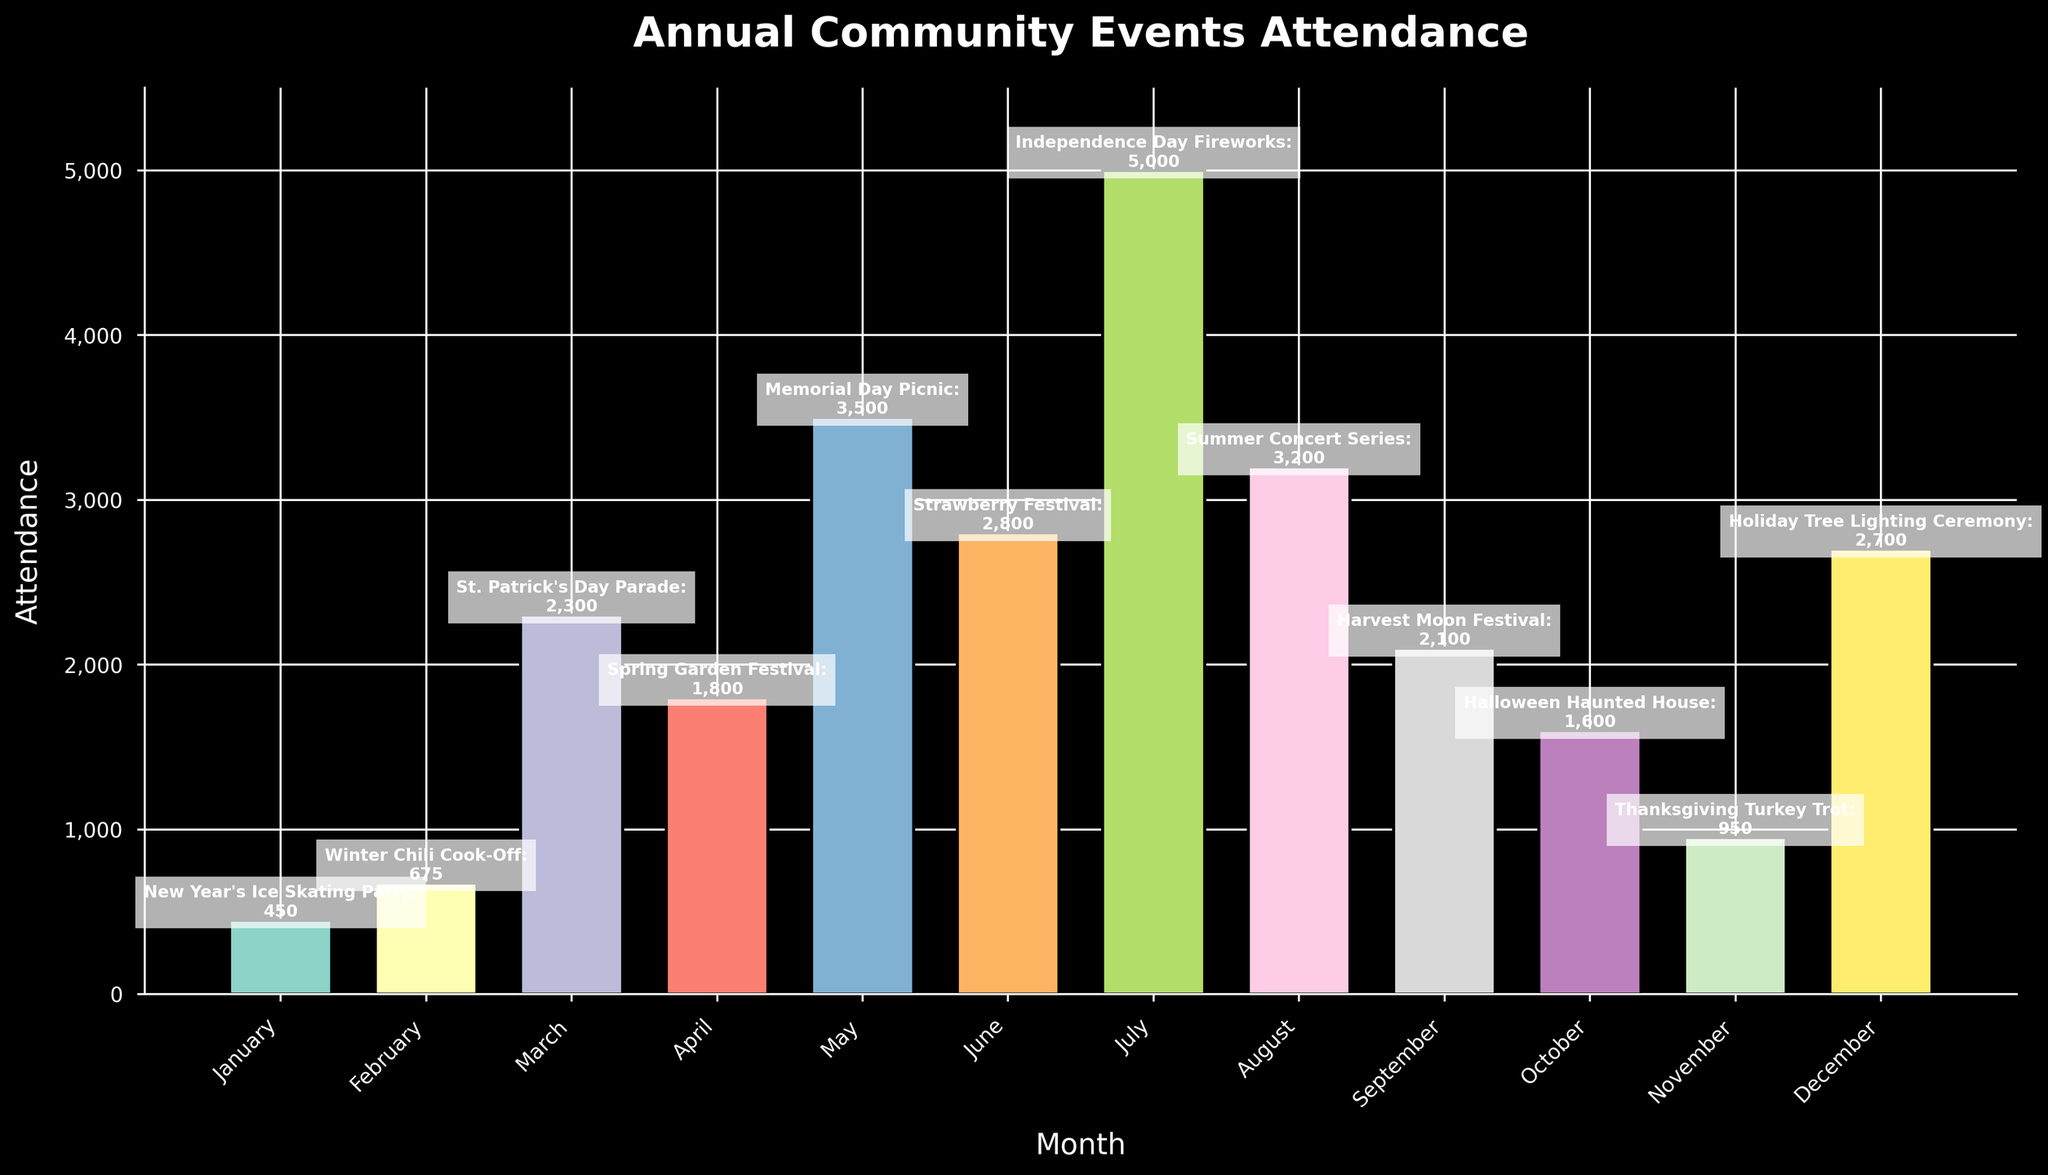What month has the highest attendance in the community events? Looking at the bar chart, the month with the tallest bar represents the highest attendance. The July bar is the tallest.
Answer: July Which event had the lowest attendance, and in which month did it occur? Observing the bar chart, find the shortest bar which represents the lowest attendance. The shortest bar corresponds to the event in January.
Answer: New Year's Ice Skating Party in January How much higher is the attendance in May compared to April? Locate the bars for May and April. The attendance for May is 3500, and for April, it is 1800. Subtract April's attendance from May's (3500 - 1800 = 1700).
Answer: 1700 What are the three months with the highest event attendance? Identify and compare the height of all the bars. The three tallest bars are in July (5000), May (3500), and August (3200).
Answer: July, May, August Which event saw greater attendance: the Spring Garden Festival or the Summer Concert Series? Compare the heights of the bars for the respective months April (Spring Garden Festival, 1800) and August (Summer Concert Series, 3200). The bar for August is taller.
Answer: Summer Concert Series What is the total attendance for the first quarter (January, February, March)? Sum the attendance values for January (450), February (675), and March (2300). The total is 450 + 675 + 2300 = 3425.
Answer: 3425 Rank the months with attendance over 2000 from highest to lowest. Identify the bars with attendance over 2000: July (5000), May (3500), August (3200), June (2800), September (2100), March (2300), April (1800). Then, sort them in descending order: July, May, August, June, March, September, April.
Answer: July, May, August, June, March, September, April Is the attendance in December higher or lower than in October? Compare the heights of the bars for October and December. December's attendance (2700) is higher than October's (1600).
Answer: Higher What's the average monthly attendance for the events in the second quarter (April, May, June)? Find the attendance for April (1800), May (3500), and June (2800). Calculate the average by summing them and dividing by 3: (1800 + 3500 + 2800) / 3 = 2700.
Answer: 2700 How does the Thanksgiving Turkey Trot attendance compare to the New Year's Ice Skating Party? Compare the heights of the bars for November (Thanksgiving Turkey Trot, 950) and January (New Year's Ice Skating Party, 450). The attendance in November is higher.
Answer: Higher 